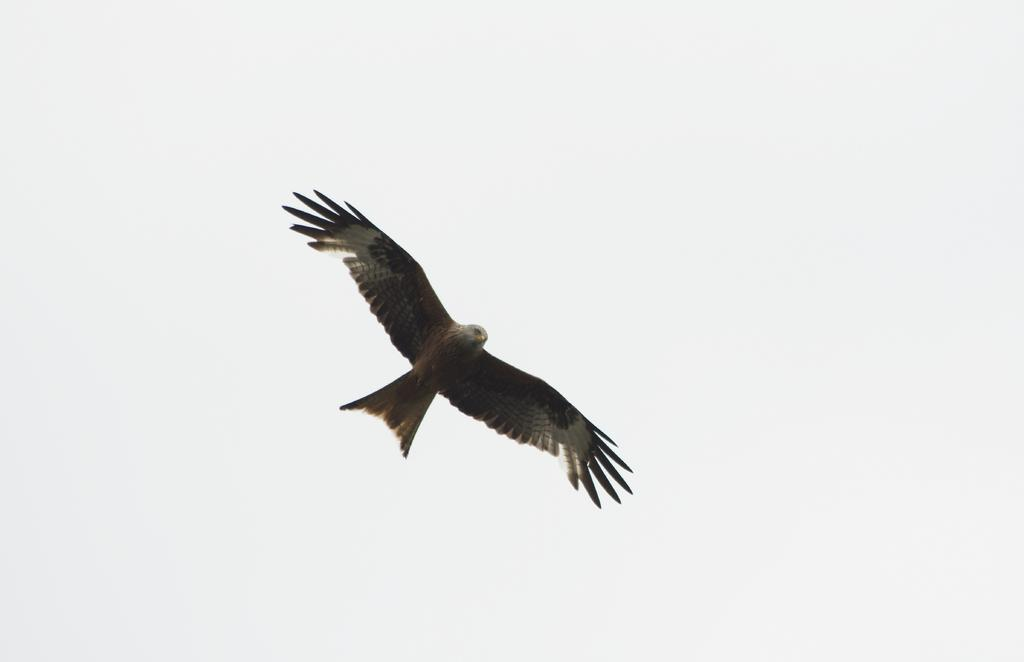What type of animal can be seen in the image? There is a bird in the image. What is the bird doing in the image? The bird is flying in the sky. What type of fowl can be seen performing a twist in the image? There is no fowl performing a twist in the image; it only features a bird flying in the sky. 